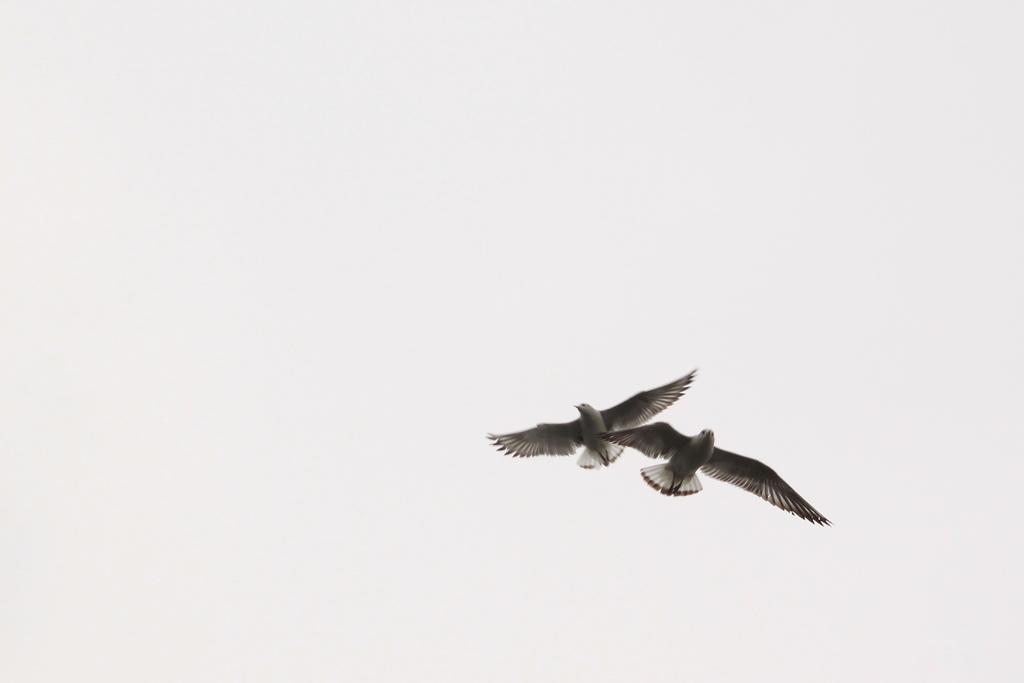Could you give a brief overview of what you see in this image? In this image we can see two birds are flying and there is a white background. 